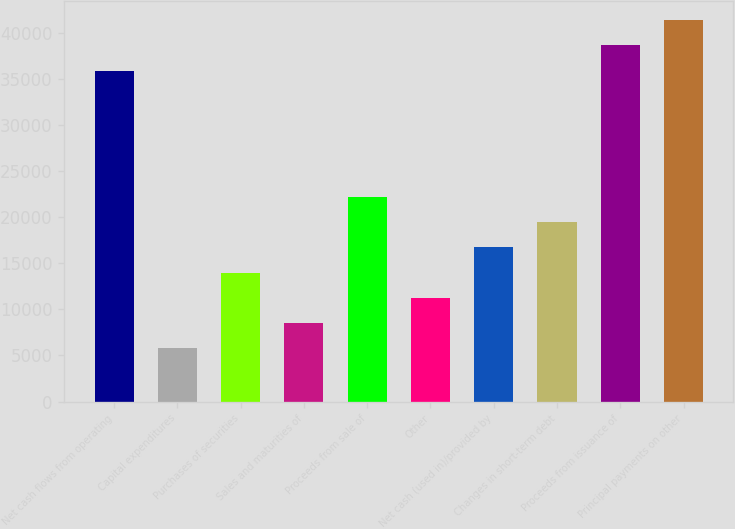Convert chart to OTSL. <chart><loc_0><loc_0><loc_500><loc_500><bar_chart><fcel>Net cash flows from operating<fcel>Capital expenditures<fcel>Purchases of securities<fcel>Sales and maturities of<fcel>Proceeds from sale of<fcel>Other<fcel>Net cash (used in)/provided by<fcel>Changes in short-term debt<fcel>Proceeds from issuance of<fcel>Principal payments on other<nl><fcel>35905.1<fcel>5757.4<fcel>13979.5<fcel>8498.1<fcel>22201.6<fcel>11238.8<fcel>16720.2<fcel>19460.9<fcel>38645.8<fcel>41386.5<nl></chart> 